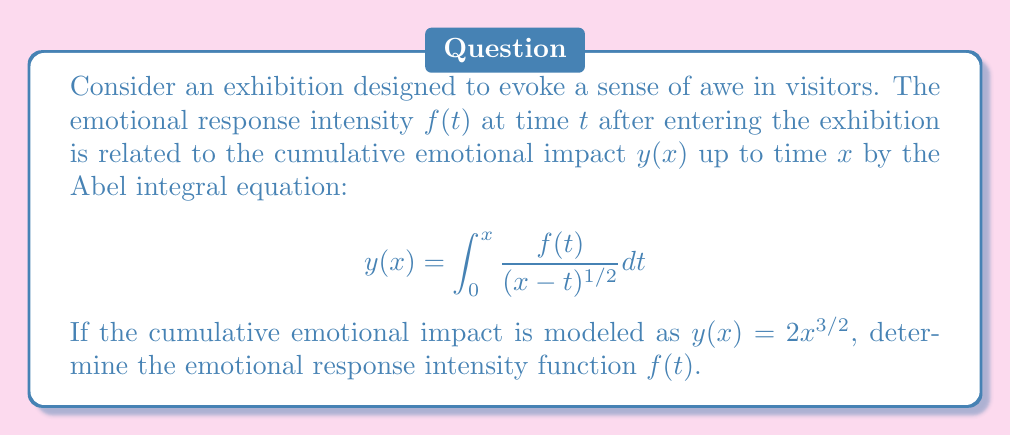Can you answer this question? To solve this Abel integral equation, we'll follow these steps:

1) The general form of an Abel integral equation is:
   $$y(x) = \int_0^x \frac{f(t)}{(x-t)^{\alpha}} dt$$
   where $0 < \alpha < 1$. In our case, $\alpha = 1/2$.

2) The solution to this equation is given by:
   $$f(t) = \frac{1}{\pi} \frac{d}{dt} \int_0^t \frac{y'(x)}{(t-x)^{1-\alpha}} dx$$

3) In our case, $y(x) = 2x^{3/2}$, so $y'(x) = 3x^{1/2}$.

4) Substituting into the solution formula:
   $$f(t) = \frac{1}{\pi} \frac{d}{dt} \int_0^t \frac{3x^{1/2}}{(t-x)^{1/2}} dx$$

5) To evaluate this, we can use the substitution $x = tu$:
   $$f(t) = \frac{3}{\pi} \frac{d}{dt} \int_0^1 \frac{(tu)^{1/2}}{(t-tu)^{1/2}} t du$$

6) Simplifying:
   $$f(t) = \frac{3}{\pi} \frac{d}{dt} [t \int_0^1 \frac{u^{1/2}}{(1-u)^{1/2}} du]$$

7) The integral $\int_0^1 \frac{u^{1/2}}{(1-u)^{1/2}} du$ is a constant (it's actually equal to $\pi/2$).

8) So we have:
   $$f(t) = \frac{3}{\pi} \frac{d}{dt} [Ct] = \frac{3}{\pi} C = \frac{3}{\pi} \frac{\pi}{2} = \frac{3}{2}$$

Therefore, the emotional response intensity function $f(t)$ is constant and equal to $3/2$.
Answer: $f(t) = \frac{3}{2}$ 